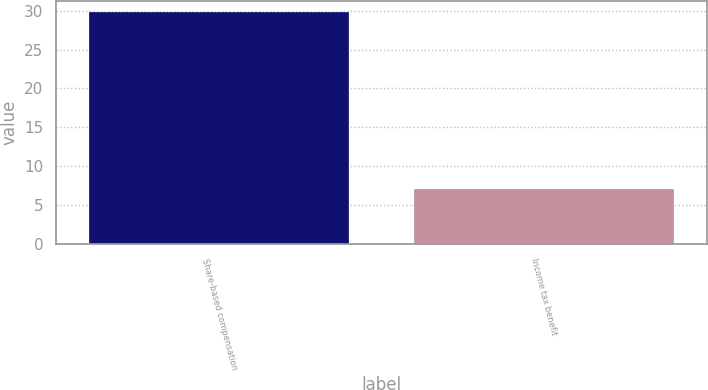Convert chart to OTSL. <chart><loc_0><loc_0><loc_500><loc_500><bar_chart><fcel>Share-based compensation<fcel>Income tax benefit<nl><fcel>29.8<fcel>7.1<nl></chart> 